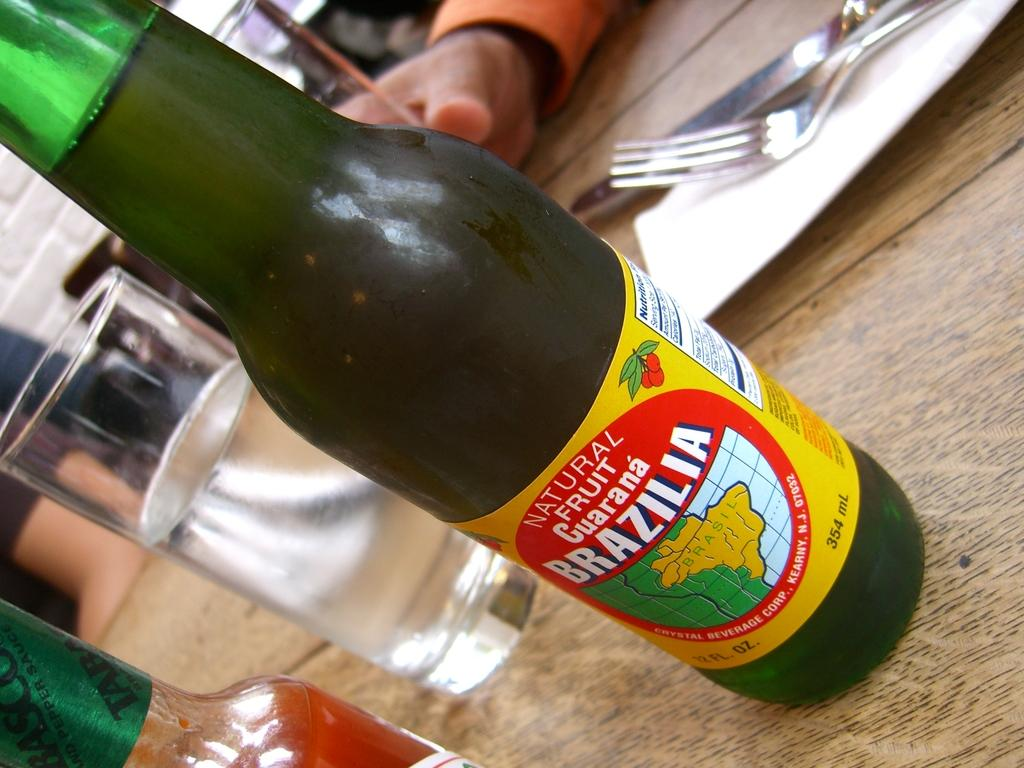<image>
Give a short and clear explanation of the subsequent image. A bottle of fruit drink from Brazil is on top of a table. 